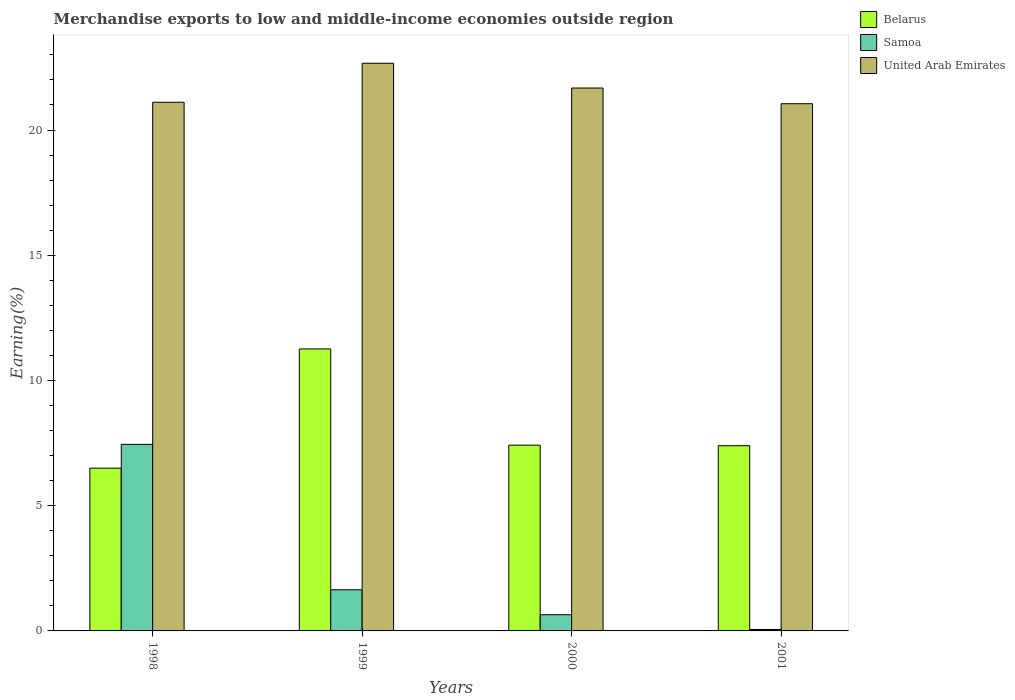How many different coloured bars are there?
Offer a very short reply. 3. How many groups of bars are there?
Provide a succinct answer. 4. Are the number of bars per tick equal to the number of legend labels?
Provide a succinct answer. Yes. What is the label of the 4th group of bars from the left?
Make the answer very short. 2001. What is the percentage of amount earned from merchandise exports in United Arab Emirates in 2001?
Your answer should be very brief. 21.05. Across all years, what is the maximum percentage of amount earned from merchandise exports in Belarus?
Keep it short and to the point. 11.26. Across all years, what is the minimum percentage of amount earned from merchandise exports in United Arab Emirates?
Keep it short and to the point. 21.05. What is the total percentage of amount earned from merchandise exports in Belarus in the graph?
Ensure brevity in your answer.  32.57. What is the difference between the percentage of amount earned from merchandise exports in Belarus in 1998 and that in 2001?
Your answer should be very brief. -0.9. What is the difference between the percentage of amount earned from merchandise exports in Belarus in 2000 and the percentage of amount earned from merchandise exports in United Arab Emirates in 2001?
Ensure brevity in your answer.  -13.63. What is the average percentage of amount earned from merchandise exports in Belarus per year?
Offer a terse response. 8.14. In the year 2001, what is the difference between the percentage of amount earned from merchandise exports in Belarus and percentage of amount earned from merchandise exports in Samoa?
Provide a succinct answer. 7.34. In how many years, is the percentage of amount earned from merchandise exports in Belarus greater than 11 %?
Your answer should be very brief. 1. What is the ratio of the percentage of amount earned from merchandise exports in United Arab Emirates in 2000 to that in 2001?
Your answer should be compact. 1.03. Is the difference between the percentage of amount earned from merchandise exports in Belarus in 1998 and 2000 greater than the difference between the percentage of amount earned from merchandise exports in Samoa in 1998 and 2000?
Provide a short and direct response. No. What is the difference between the highest and the second highest percentage of amount earned from merchandise exports in Samoa?
Keep it short and to the point. 5.81. What is the difference between the highest and the lowest percentage of amount earned from merchandise exports in Samoa?
Your response must be concise. 7.39. What does the 3rd bar from the left in 1999 represents?
Your answer should be compact. United Arab Emirates. What does the 3rd bar from the right in 1999 represents?
Offer a very short reply. Belarus. Is it the case that in every year, the sum of the percentage of amount earned from merchandise exports in Belarus and percentage of amount earned from merchandise exports in United Arab Emirates is greater than the percentage of amount earned from merchandise exports in Samoa?
Offer a very short reply. Yes. How many bars are there?
Your answer should be very brief. 12. Are all the bars in the graph horizontal?
Make the answer very short. No. Are the values on the major ticks of Y-axis written in scientific E-notation?
Provide a succinct answer. No. Does the graph contain any zero values?
Keep it short and to the point. No. Does the graph contain grids?
Provide a short and direct response. No. Where does the legend appear in the graph?
Ensure brevity in your answer.  Top right. How many legend labels are there?
Keep it short and to the point. 3. What is the title of the graph?
Keep it short and to the point. Merchandise exports to low and middle-income economies outside region. What is the label or title of the Y-axis?
Your response must be concise. Earning(%). What is the Earning(%) in Belarus in 1998?
Give a very brief answer. 6.5. What is the Earning(%) in Samoa in 1998?
Offer a terse response. 7.45. What is the Earning(%) of United Arab Emirates in 1998?
Offer a very short reply. 21.11. What is the Earning(%) in Belarus in 1999?
Your answer should be compact. 11.26. What is the Earning(%) of Samoa in 1999?
Ensure brevity in your answer.  1.64. What is the Earning(%) in United Arab Emirates in 1999?
Offer a terse response. 22.67. What is the Earning(%) in Belarus in 2000?
Your response must be concise. 7.42. What is the Earning(%) of Samoa in 2000?
Your answer should be very brief. 0.65. What is the Earning(%) of United Arab Emirates in 2000?
Your response must be concise. 21.68. What is the Earning(%) of Belarus in 2001?
Offer a terse response. 7.4. What is the Earning(%) in Samoa in 2001?
Ensure brevity in your answer.  0.06. What is the Earning(%) of United Arab Emirates in 2001?
Offer a very short reply. 21.05. Across all years, what is the maximum Earning(%) in Belarus?
Ensure brevity in your answer.  11.26. Across all years, what is the maximum Earning(%) of Samoa?
Provide a short and direct response. 7.45. Across all years, what is the maximum Earning(%) of United Arab Emirates?
Ensure brevity in your answer.  22.67. Across all years, what is the minimum Earning(%) in Belarus?
Your answer should be compact. 6.5. Across all years, what is the minimum Earning(%) in Samoa?
Ensure brevity in your answer.  0.06. Across all years, what is the minimum Earning(%) in United Arab Emirates?
Ensure brevity in your answer.  21.05. What is the total Earning(%) in Belarus in the graph?
Provide a succinct answer. 32.57. What is the total Earning(%) of Samoa in the graph?
Give a very brief answer. 9.8. What is the total Earning(%) of United Arab Emirates in the graph?
Make the answer very short. 86.5. What is the difference between the Earning(%) of Belarus in 1998 and that in 1999?
Your answer should be very brief. -4.76. What is the difference between the Earning(%) of Samoa in 1998 and that in 1999?
Ensure brevity in your answer.  5.81. What is the difference between the Earning(%) in United Arab Emirates in 1998 and that in 1999?
Your answer should be very brief. -1.56. What is the difference between the Earning(%) of Belarus in 1998 and that in 2000?
Your answer should be very brief. -0.92. What is the difference between the Earning(%) of Samoa in 1998 and that in 2000?
Provide a succinct answer. 6.8. What is the difference between the Earning(%) of United Arab Emirates in 1998 and that in 2000?
Offer a very short reply. -0.57. What is the difference between the Earning(%) in Belarus in 1998 and that in 2001?
Provide a short and direct response. -0.9. What is the difference between the Earning(%) in Samoa in 1998 and that in 2001?
Your answer should be very brief. 7.39. What is the difference between the Earning(%) of United Arab Emirates in 1998 and that in 2001?
Provide a succinct answer. 0.06. What is the difference between the Earning(%) of Belarus in 1999 and that in 2000?
Offer a very short reply. 3.84. What is the difference between the Earning(%) of Samoa in 1999 and that in 2000?
Make the answer very short. 1. What is the difference between the Earning(%) of United Arab Emirates in 1999 and that in 2000?
Provide a succinct answer. 0.99. What is the difference between the Earning(%) in Belarus in 1999 and that in 2001?
Ensure brevity in your answer.  3.86. What is the difference between the Earning(%) of Samoa in 1999 and that in 2001?
Your answer should be compact. 1.58. What is the difference between the Earning(%) in United Arab Emirates in 1999 and that in 2001?
Offer a terse response. 1.62. What is the difference between the Earning(%) in Belarus in 2000 and that in 2001?
Offer a very short reply. 0.02. What is the difference between the Earning(%) in Samoa in 2000 and that in 2001?
Give a very brief answer. 0.59. What is the difference between the Earning(%) of United Arab Emirates in 2000 and that in 2001?
Your answer should be very brief. 0.63. What is the difference between the Earning(%) of Belarus in 1998 and the Earning(%) of Samoa in 1999?
Offer a very short reply. 4.86. What is the difference between the Earning(%) in Belarus in 1998 and the Earning(%) in United Arab Emirates in 1999?
Provide a succinct answer. -16.17. What is the difference between the Earning(%) of Samoa in 1998 and the Earning(%) of United Arab Emirates in 1999?
Offer a very short reply. -15.22. What is the difference between the Earning(%) in Belarus in 1998 and the Earning(%) in Samoa in 2000?
Your answer should be very brief. 5.85. What is the difference between the Earning(%) of Belarus in 1998 and the Earning(%) of United Arab Emirates in 2000?
Keep it short and to the point. -15.18. What is the difference between the Earning(%) in Samoa in 1998 and the Earning(%) in United Arab Emirates in 2000?
Make the answer very short. -14.23. What is the difference between the Earning(%) in Belarus in 1998 and the Earning(%) in Samoa in 2001?
Make the answer very short. 6.44. What is the difference between the Earning(%) in Belarus in 1998 and the Earning(%) in United Arab Emirates in 2001?
Ensure brevity in your answer.  -14.55. What is the difference between the Earning(%) of Samoa in 1998 and the Earning(%) of United Arab Emirates in 2001?
Offer a very short reply. -13.6. What is the difference between the Earning(%) of Belarus in 1999 and the Earning(%) of Samoa in 2000?
Make the answer very short. 10.61. What is the difference between the Earning(%) in Belarus in 1999 and the Earning(%) in United Arab Emirates in 2000?
Provide a succinct answer. -10.42. What is the difference between the Earning(%) in Samoa in 1999 and the Earning(%) in United Arab Emirates in 2000?
Provide a short and direct response. -20.04. What is the difference between the Earning(%) of Belarus in 1999 and the Earning(%) of Samoa in 2001?
Offer a very short reply. 11.2. What is the difference between the Earning(%) of Belarus in 1999 and the Earning(%) of United Arab Emirates in 2001?
Keep it short and to the point. -9.79. What is the difference between the Earning(%) in Samoa in 1999 and the Earning(%) in United Arab Emirates in 2001?
Ensure brevity in your answer.  -19.41. What is the difference between the Earning(%) of Belarus in 2000 and the Earning(%) of Samoa in 2001?
Provide a succinct answer. 7.36. What is the difference between the Earning(%) of Belarus in 2000 and the Earning(%) of United Arab Emirates in 2001?
Ensure brevity in your answer.  -13.63. What is the difference between the Earning(%) in Samoa in 2000 and the Earning(%) in United Arab Emirates in 2001?
Offer a terse response. -20.4. What is the average Earning(%) in Belarus per year?
Provide a short and direct response. 8.14. What is the average Earning(%) of Samoa per year?
Keep it short and to the point. 2.45. What is the average Earning(%) in United Arab Emirates per year?
Ensure brevity in your answer.  21.63. In the year 1998, what is the difference between the Earning(%) in Belarus and Earning(%) in Samoa?
Keep it short and to the point. -0.95. In the year 1998, what is the difference between the Earning(%) of Belarus and Earning(%) of United Arab Emirates?
Ensure brevity in your answer.  -14.61. In the year 1998, what is the difference between the Earning(%) in Samoa and Earning(%) in United Arab Emirates?
Make the answer very short. -13.66. In the year 1999, what is the difference between the Earning(%) of Belarus and Earning(%) of Samoa?
Make the answer very short. 9.62. In the year 1999, what is the difference between the Earning(%) in Belarus and Earning(%) in United Arab Emirates?
Offer a very short reply. -11.41. In the year 1999, what is the difference between the Earning(%) in Samoa and Earning(%) in United Arab Emirates?
Ensure brevity in your answer.  -21.02. In the year 2000, what is the difference between the Earning(%) of Belarus and Earning(%) of Samoa?
Keep it short and to the point. 6.77. In the year 2000, what is the difference between the Earning(%) of Belarus and Earning(%) of United Arab Emirates?
Give a very brief answer. -14.26. In the year 2000, what is the difference between the Earning(%) of Samoa and Earning(%) of United Arab Emirates?
Provide a succinct answer. -21.03. In the year 2001, what is the difference between the Earning(%) in Belarus and Earning(%) in Samoa?
Ensure brevity in your answer.  7.34. In the year 2001, what is the difference between the Earning(%) in Belarus and Earning(%) in United Arab Emirates?
Give a very brief answer. -13.65. In the year 2001, what is the difference between the Earning(%) in Samoa and Earning(%) in United Arab Emirates?
Provide a short and direct response. -20.99. What is the ratio of the Earning(%) in Belarus in 1998 to that in 1999?
Provide a succinct answer. 0.58. What is the ratio of the Earning(%) in Samoa in 1998 to that in 1999?
Your response must be concise. 4.54. What is the ratio of the Earning(%) in United Arab Emirates in 1998 to that in 1999?
Your response must be concise. 0.93. What is the ratio of the Earning(%) in Belarus in 1998 to that in 2000?
Your answer should be very brief. 0.88. What is the ratio of the Earning(%) of Samoa in 1998 to that in 2000?
Offer a very short reply. 11.52. What is the ratio of the Earning(%) in United Arab Emirates in 1998 to that in 2000?
Keep it short and to the point. 0.97. What is the ratio of the Earning(%) in Belarus in 1998 to that in 2001?
Offer a terse response. 0.88. What is the ratio of the Earning(%) of Samoa in 1998 to that in 2001?
Offer a terse response. 126.17. What is the ratio of the Earning(%) of United Arab Emirates in 1998 to that in 2001?
Your answer should be compact. 1. What is the ratio of the Earning(%) in Belarus in 1999 to that in 2000?
Offer a very short reply. 1.52. What is the ratio of the Earning(%) of Samoa in 1999 to that in 2000?
Offer a very short reply. 2.54. What is the ratio of the Earning(%) in United Arab Emirates in 1999 to that in 2000?
Give a very brief answer. 1.05. What is the ratio of the Earning(%) of Belarus in 1999 to that in 2001?
Give a very brief answer. 1.52. What is the ratio of the Earning(%) in Samoa in 1999 to that in 2001?
Provide a short and direct response. 27.81. What is the ratio of the Earning(%) in United Arab Emirates in 1999 to that in 2001?
Give a very brief answer. 1.08. What is the ratio of the Earning(%) in Samoa in 2000 to that in 2001?
Offer a terse response. 10.95. What is the ratio of the Earning(%) of United Arab Emirates in 2000 to that in 2001?
Ensure brevity in your answer.  1.03. What is the difference between the highest and the second highest Earning(%) of Belarus?
Offer a terse response. 3.84. What is the difference between the highest and the second highest Earning(%) in Samoa?
Your answer should be very brief. 5.81. What is the difference between the highest and the lowest Earning(%) in Belarus?
Your answer should be very brief. 4.76. What is the difference between the highest and the lowest Earning(%) of Samoa?
Make the answer very short. 7.39. What is the difference between the highest and the lowest Earning(%) in United Arab Emirates?
Your answer should be compact. 1.62. 